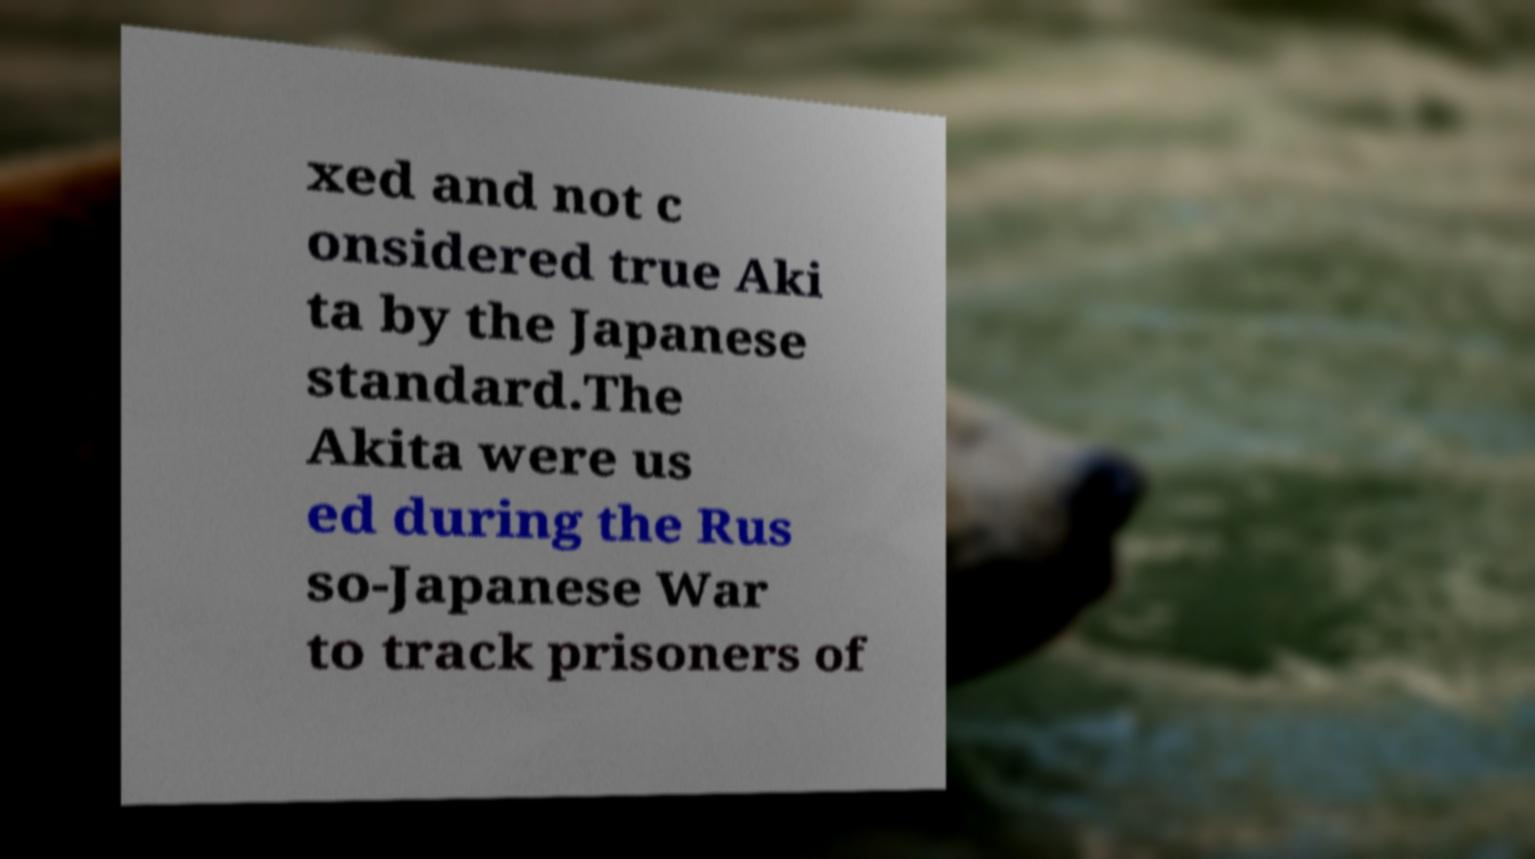Please identify and transcribe the text found in this image. xed and not c onsidered true Aki ta by the Japanese standard.The Akita were us ed during the Rus so-Japanese War to track prisoners of 